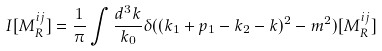<formula> <loc_0><loc_0><loc_500><loc_500>I [ M ^ { i j } _ { R } ] = \frac { 1 } { \pi } \int \frac { d ^ { 3 } k } { k _ { 0 } } \delta ( ( k _ { 1 } + p _ { 1 } - k _ { 2 } - k ) ^ { 2 } - m ^ { 2 } ) [ M ^ { i j } _ { R } ]</formula> 